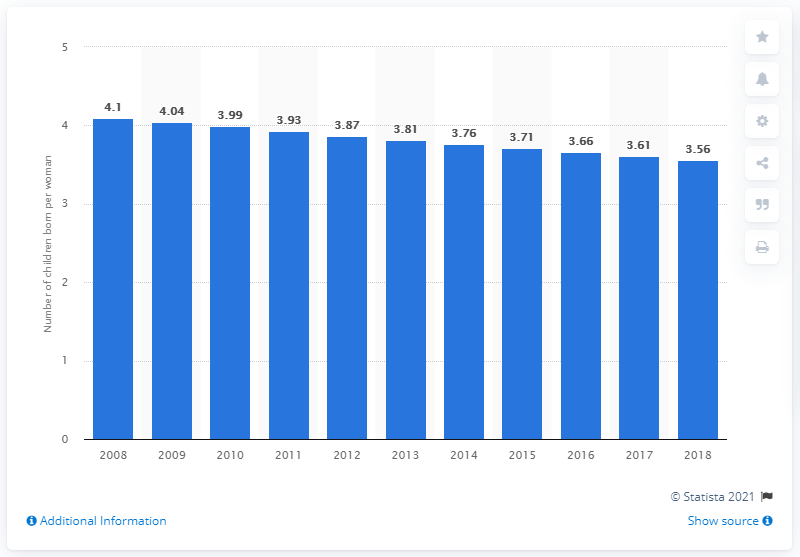Mention a couple of crucial points in this snapshot. The fertility rate in Papua New Guinea in 2018 was 3.56. 